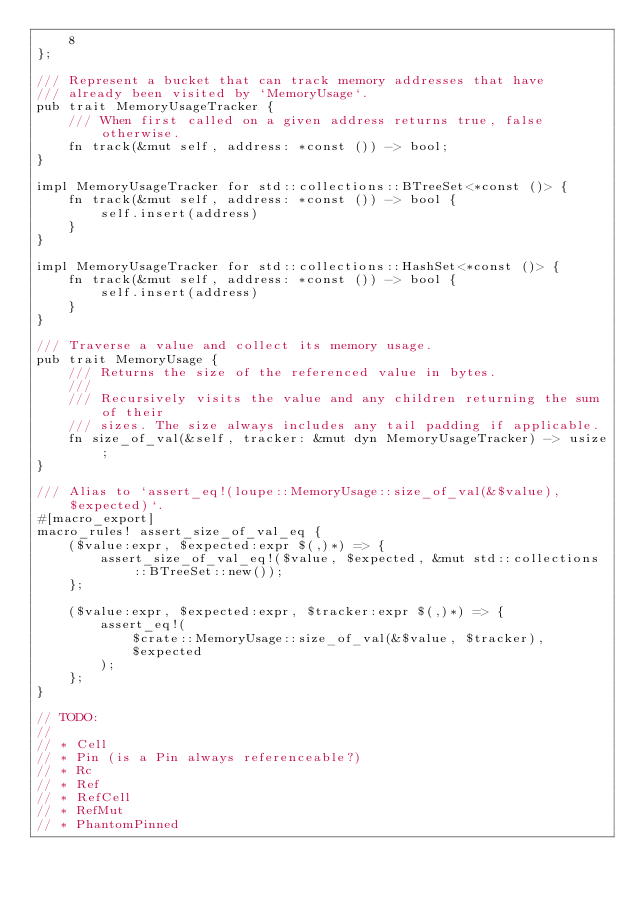<code> <loc_0><loc_0><loc_500><loc_500><_Rust_>    8
};

/// Represent a bucket that can track memory addresses that have
/// already been visited by `MemoryUsage`.
pub trait MemoryUsageTracker {
    /// When first called on a given address returns true, false otherwise.
    fn track(&mut self, address: *const ()) -> bool;
}

impl MemoryUsageTracker for std::collections::BTreeSet<*const ()> {
    fn track(&mut self, address: *const ()) -> bool {
        self.insert(address)
    }
}

impl MemoryUsageTracker for std::collections::HashSet<*const ()> {
    fn track(&mut self, address: *const ()) -> bool {
        self.insert(address)
    }
}

/// Traverse a value and collect its memory usage.
pub trait MemoryUsage {
    /// Returns the size of the referenced value in bytes.
    ///
    /// Recursively visits the value and any children returning the sum of their
    /// sizes. The size always includes any tail padding if applicable.
    fn size_of_val(&self, tracker: &mut dyn MemoryUsageTracker) -> usize;
}

/// Alias to `assert_eq!(loupe::MemoryUsage::size_of_val(&$value), $expected)`.
#[macro_export]
macro_rules! assert_size_of_val_eq {
    ($value:expr, $expected:expr $(,)*) => {
        assert_size_of_val_eq!($value, $expected, &mut std::collections::BTreeSet::new());
    };

    ($value:expr, $expected:expr, $tracker:expr $(,)*) => {
        assert_eq!(
            $crate::MemoryUsage::size_of_val(&$value, $tracker),
            $expected
        );
    };
}

// TODO:
//
// * Cell
// * Pin (is a Pin always referenceable?)
// * Rc
// * Ref
// * RefCell
// * RefMut
// * PhantomPinned
</code> 